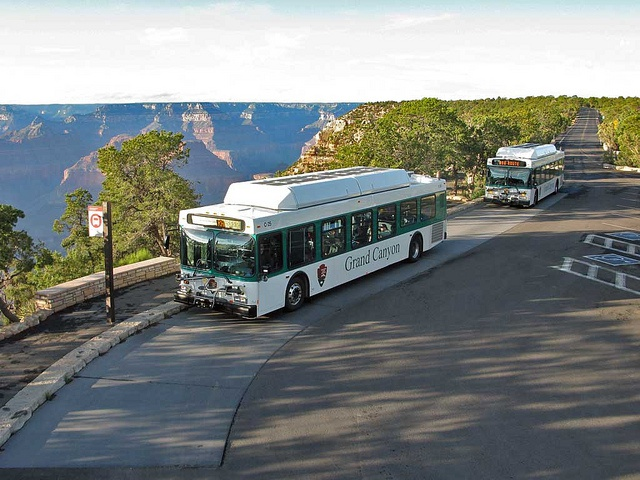Describe the objects in this image and their specific colors. I can see bus in lightblue, black, darkgray, white, and gray tones and bus in lightblue, black, gray, darkgray, and lightgray tones in this image. 